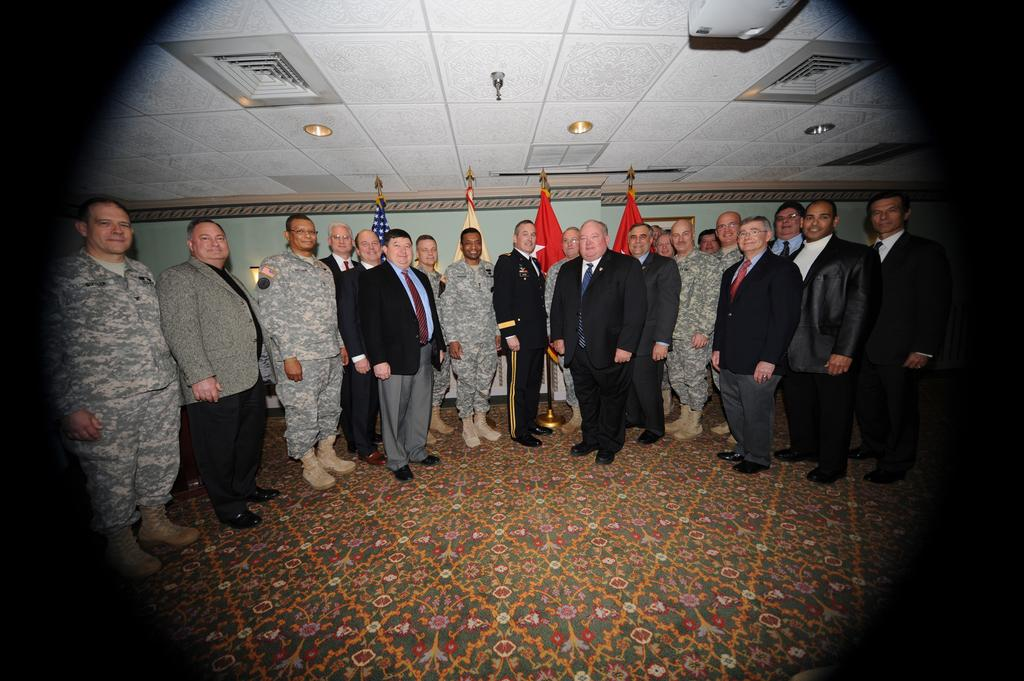What can be seen in the image regarding people? There are men standing in the image. What type of clothing are some of the men wearing? Some of the men are wearing coats. What can be seen in the background of the image? There are four flags visible in the background and a wall. Can you tell me how many dogs are present in the image? There are no dogs present in the image. What type of iron is being used by the men in the image? There is no iron visible in the image, and the men are not using any iron. 